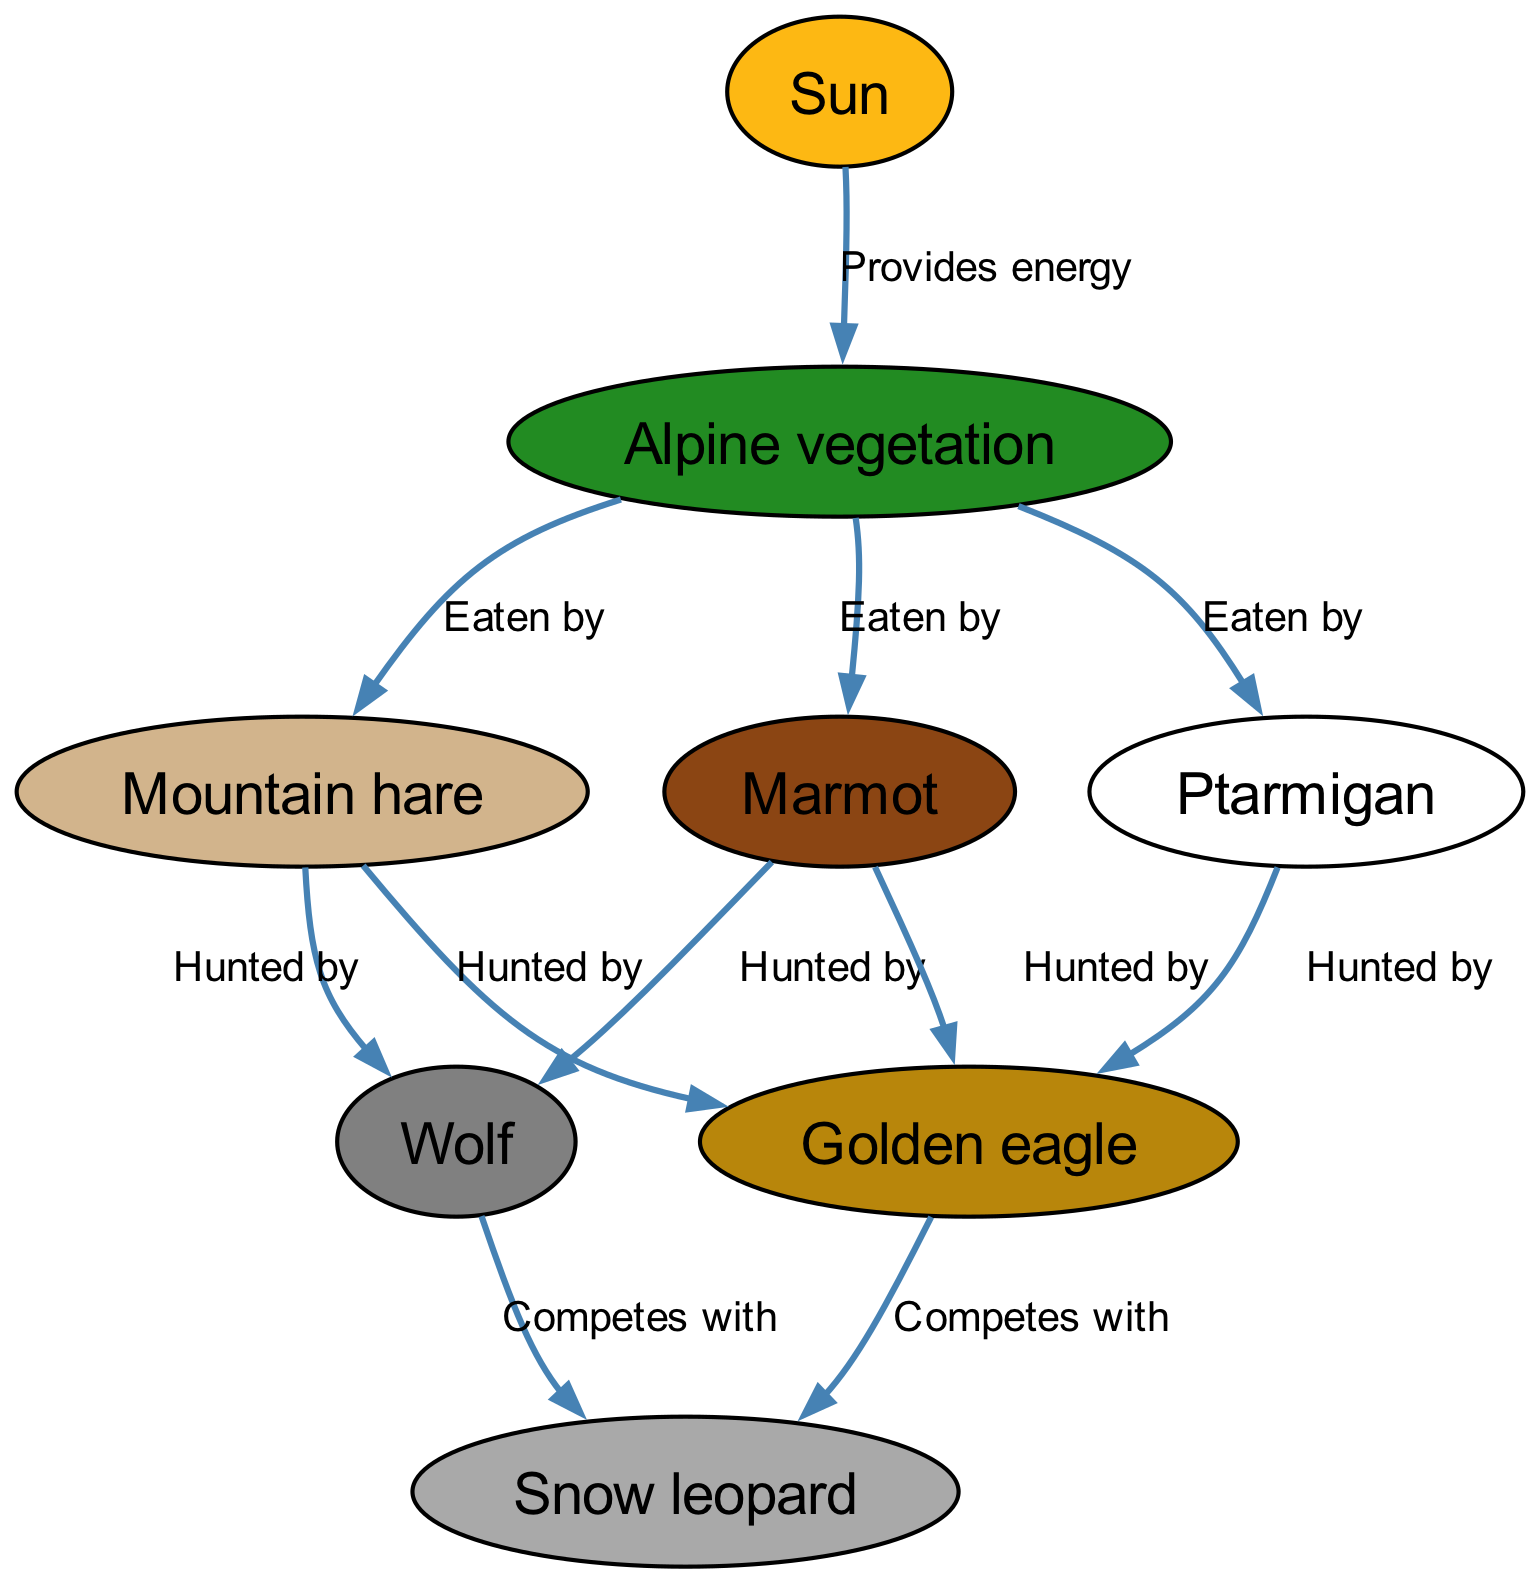What organism provides energy to alpine vegetation? The diagram shows a directed edge from "Sun" to "Alpine vegetation," indicating that the Sun is the source of energy for the vegetation.
Answer: Sun How many organisms are directly eaten by alpine vegetation? The diagram has three directed edges leading from "Alpine vegetation" to "Mountain hare," "Marmot," and "Ptarmigan," showing that there are three organisms that are eaten by it.
Answer: 3 Which organism hunts both mountain hare and marmot? By examining the diagram, both "Mountain hare" and "Marmot" have directed edges leading to "Golden eagle," indicating that this is the organism that hunts both.
Answer: Golden eagle What is the relationship between the golden eagle and the snow leopard? The diagram reveals a competition relationship where "Golden eagle" competes with "Snow leopard," as indicated by the directed edge with the label "Competes with."
Answer: Competes with What is the primary food source for the golden eagle? The "Golden eagle" is depicted as hunting "Mountain hare," "Marmot," and "Ptarmigan," meaning that any of these can be considered a primary food source based on the diagram's relationships.
Answer: Mountain hare How many competitive relationships are shown involving the snow leopard? The diagram shows two edges where "Snow leopard" competes with both "Golden eagle" and "Wolf," making a total of two competitive relationships involving the snow leopard.
Answer: 2 Which organism is at the bottom of the food chain in this diagram? "Alpine vegetation" is directly dependent on the Sun and is the starting point for the food chain, making it the bottom organism in this context.
Answer: Alpine vegetation What two organisms compete with the wolf for food? The diagram has directed edges showing that "Golden eagle" and "Snow leopard" both compete with "Wolf," indicating that these are the two organisms in competition.
Answer: Golden eagle, Snow leopard Which organism is the highest predator in the food chain? Analyzing the diagram, the "Snow leopard" is shown to be competing with the "Wolf" and "Golden eagle," suggesting it occupies the highest tier as a predator in this food chain context.
Answer: Snow leopard 